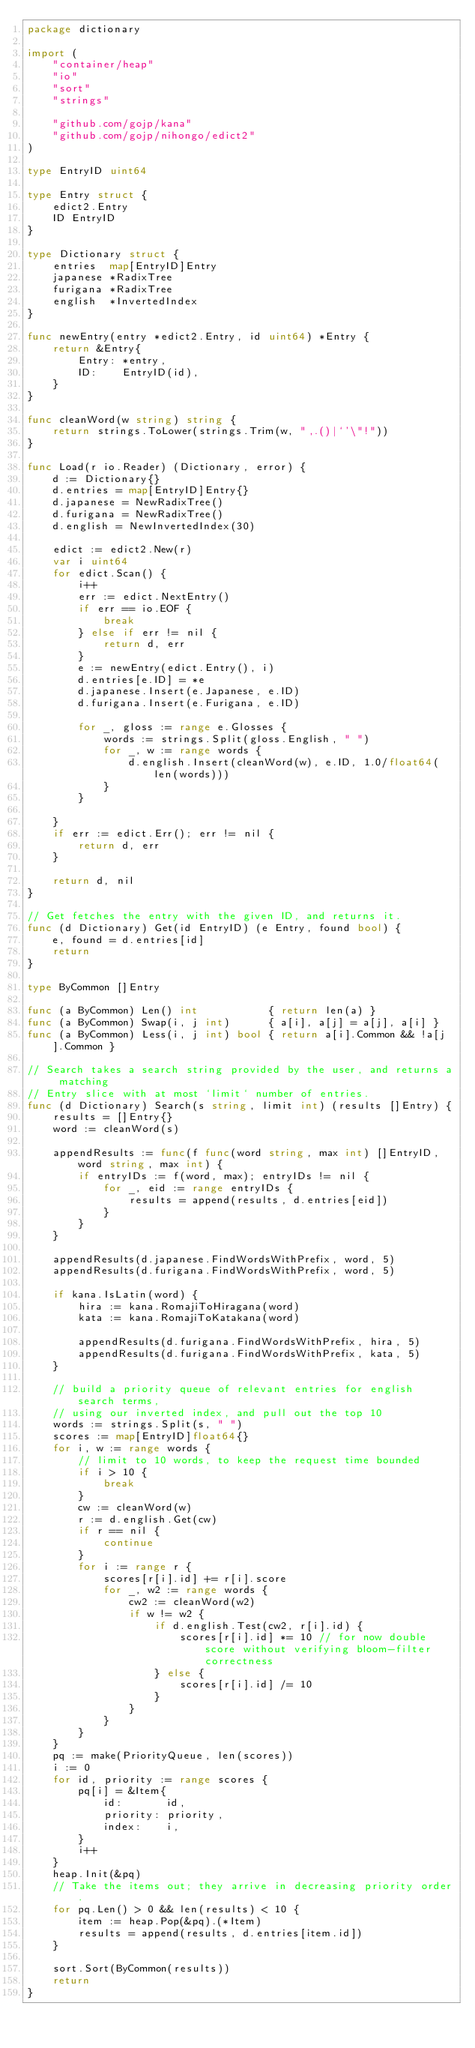<code> <loc_0><loc_0><loc_500><loc_500><_Go_>package dictionary

import (
	"container/heap"
	"io"
	"sort"
	"strings"

	"github.com/gojp/kana"
	"github.com/gojp/nihongo/edict2"
)

type EntryID uint64

type Entry struct {
	edict2.Entry
	ID EntryID
}

type Dictionary struct {
	entries  map[EntryID]Entry
	japanese *RadixTree
	furigana *RadixTree
	english  *InvertedIndex
}

func newEntry(entry *edict2.Entry, id uint64) *Entry {
	return &Entry{
		Entry: *entry,
		ID:    EntryID(id),
	}
}

func cleanWord(w string) string {
	return strings.ToLower(strings.Trim(w, ",.()|`'\"!"))
}

func Load(r io.Reader) (Dictionary, error) {
	d := Dictionary{}
	d.entries = map[EntryID]Entry{}
	d.japanese = NewRadixTree()
	d.furigana = NewRadixTree()
	d.english = NewInvertedIndex(30)

	edict := edict2.New(r)
	var i uint64
	for edict.Scan() {
		i++
		err := edict.NextEntry()
		if err == io.EOF {
			break
		} else if err != nil {
			return d, err
		}
		e := newEntry(edict.Entry(), i)
		d.entries[e.ID] = *e
		d.japanese.Insert(e.Japanese, e.ID)
		d.furigana.Insert(e.Furigana, e.ID)

		for _, gloss := range e.Glosses {
			words := strings.Split(gloss.English, " ")
			for _, w := range words {
				d.english.Insert(cleanWord(w), e.ID, 1.0/float64(len(words)))
			}
		}

	}
	if err := edict.Err(); err != nil {
		return d, err
	}

	return d, nil
}

// Get fetches the entry with the given ID, and returns it.
func (d Dictionary) Get(id EntryID) (e Entry, found bool) {
	e, found = d.entries[id]
	return
}

type ByCommon []Entry

func (a ByCommon) Len() int           { return len(a) }
func (a ByCommon) Swap(i, j int)      { a[i], a[j] = a[j], a[i] }
func (a ByCommon) Less(i, j int) bool { return a[i].Common && !a[j].Common }

// Search takes a search string provided by the user, and returns a matching
// Entry slice with at most `limit` number of entries.
func (d Dictionary) Search(s string, limit int) (results []Entry) {
	results = []Entry{}
	word := cleanWord(s)

	appendResults := func(f func(word string, max int) []EntryID, word string, max int) {
		if entryIDs := f(word, max); entryIDs != nil {
			for _, eid := range entryIDs {
				results = append(results, d.entries[eid])
			}
		}
	}

	appendResults(d.japanese.FindWordsWithPrefix, word, 5)
	appendResults(d.furigana.FindWordsWithPrefix, word, 5)

	if kana.IsLatin(word) {
		hira := kana.RomajiToHiragana(word)
		kata := kana.RomajiToKatakana(word)

		appendResults(d.furigana.FindWordsWithPrefix, hira, 5)
		appendResults(d.furigana.FindWordsWithPrefix, kata, 5)
	}

	// build a priority queue of relevant entries for english search terms,
	// using our inverted index, and pull out the top 10
	words := strings.Split(s, " ")
	scores := map[EntryID]float64{}
	for i, w := range words {
		// limit to 10 words, to keep the request time bounded
		if i > 10 {
			break
		}
		cw := cleanWord(w)
		r := d.english.Get(cw)
		if r == nil {
			continue
		}
		for i := range r {
			scores[r[i].id] += r[i].score
			for _, w2 := range words {
				cw2 := cleanWord(w2)
				if w != w2 {
					if d.english.Test(cw2, r[i].id) {
						scores[r[i].id] *= 10 // for now double score without verifying bloom-filter correctness
					} else {
						scores[r[i].id] /= 10
					}
				}
			}
		}
	}
	pq := make(PriorityQueue, len(scores))
	i := 0
	for id, priority := range scores {
		pq[i] = &Item{
			id:       id,
			priority: priority,
			index:    i,
		}
		i++
	}
	heap.Init(&pq)
	// Take the items out; they arrive in decreasing priority order.
	for pq.Len() > 0 && len(results) < 10 {
		item := heap.Pop(&pq).(*Item)
		results = append(results, d.entries[item.id])
	}

	sort.Sort(ByCommon(results))
	return
}
</code> 